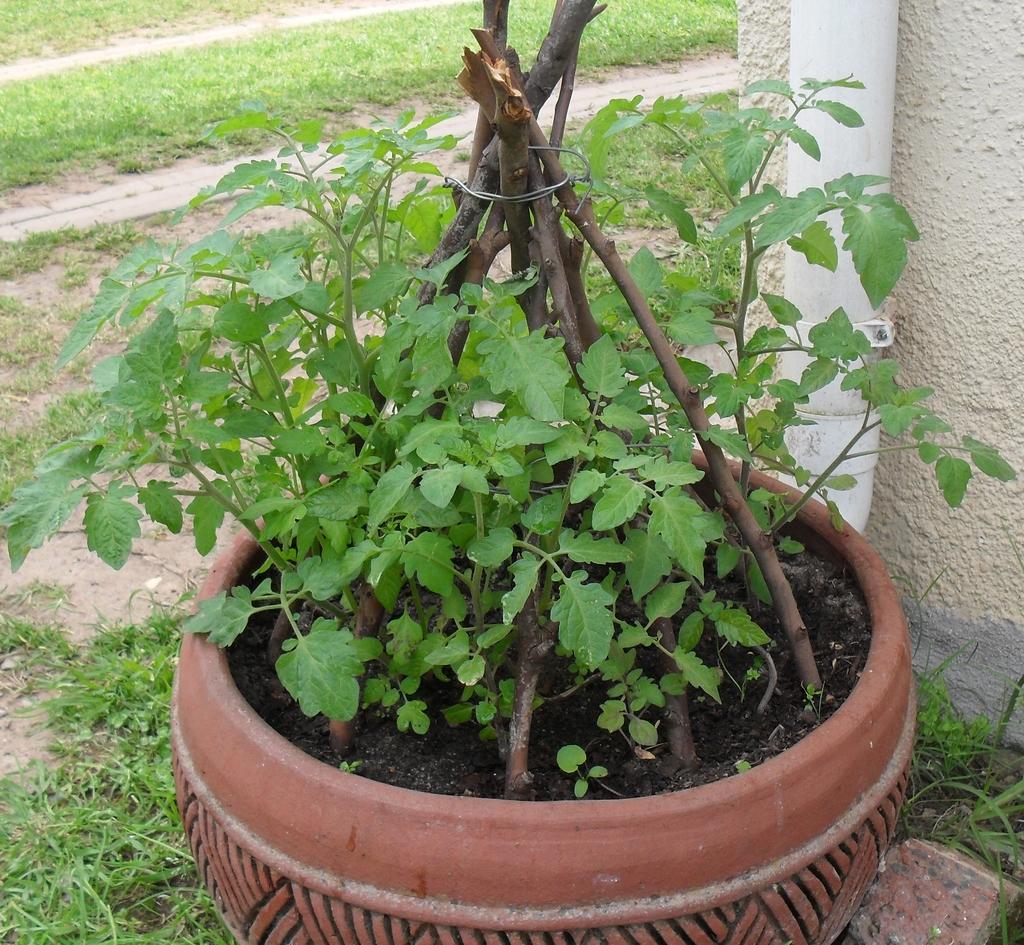In one or two sentences, can you explain what this image depicts? In this image we can see there is a potted plant. At the back there is a wall with pipeline, beside the wall there is a grass. 